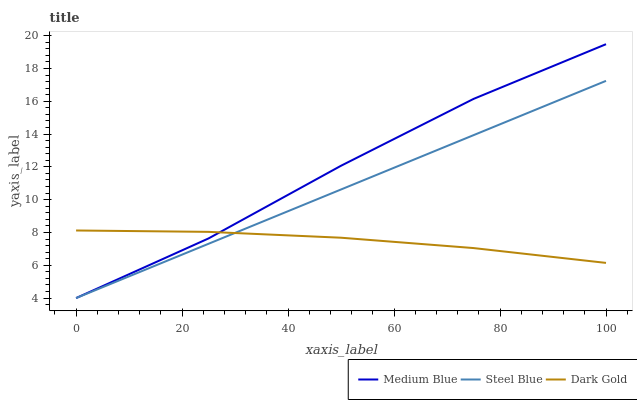Does Steel Blue have the minimum area under the curve?
Answer yes or no. No. Does Steel Blue have the maximum area under the curve?
Answer yes or no. No. Is Dark Gold the smoothest?
Answer yes or no. No. Is Dark Gold the roughest?
Answer yes or no. No. Does Dark Gold have the lowest value?
Answer yes or no. No. Does Steel Blue have the highest value?
Answer yes or no. No. 